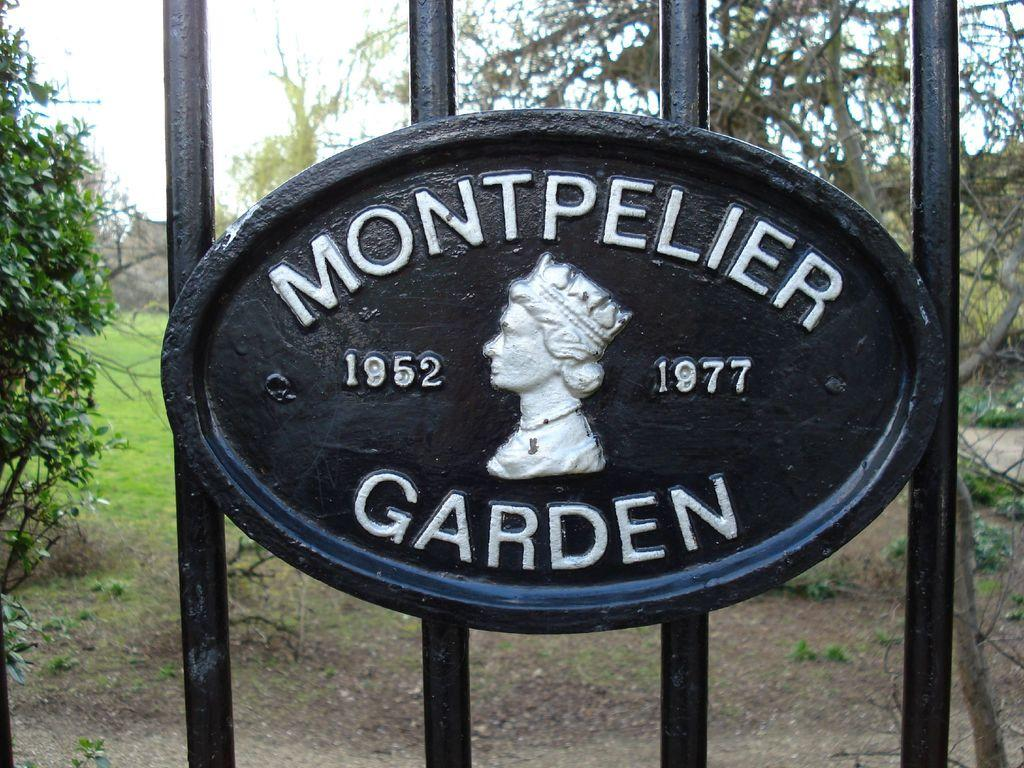What material is used for the bars in the image? The bars in the image are made of black color iron. Is there any text or markings on the iron bars? Yes, there is writing in white color on the iron bars. What can be seen in the background of the image? There are trees and grass-covered ground in the background of the image. What type of vein is visible in the image? There is no vein present in the image; it features iron bars with writing and a background of trees and grass. 